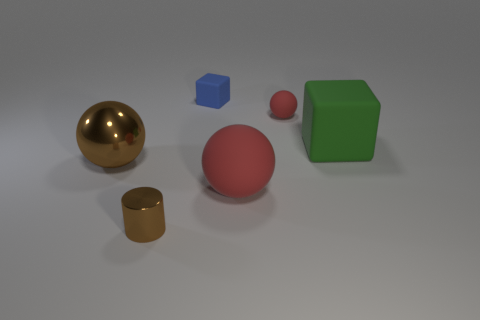There is a red matte thing in front of the large green block; does it have the same shape as the red rubber thing that is behind the green cube?
Your response must be concise. Yes. The large sphere that is to the left of the rubber sphere that is in front of the sphere to the left of the tiny block is made of what material?
Provide a succinct answer. Metal. There is a blue object that is the same size as the metallic cylinder; what is its shape?
Your answer should be very brief. Cube. Are there any large metal objects of the same color as the large cube?
Your answer should be compact. No. The brown metallic sphere has what size?
Your answer should be very brief. Large. Do the brown cylinder and the brown ball have the same material?
Ensure brevity in your answer.  Yes. How many red things are left of the large ball right of the object that is left of the small metallic cylinder?
Provide a short and direct response. 0. There is a tiny object on the left side of the blue object; what shape is it?
Your response must be concise. Cylinder. What number of other objects are the same material as the blue object?
Ensure brevity in your answer.  3. Do the big metal ball and the large matte cube have the same color?
Offer a terse response. No. 